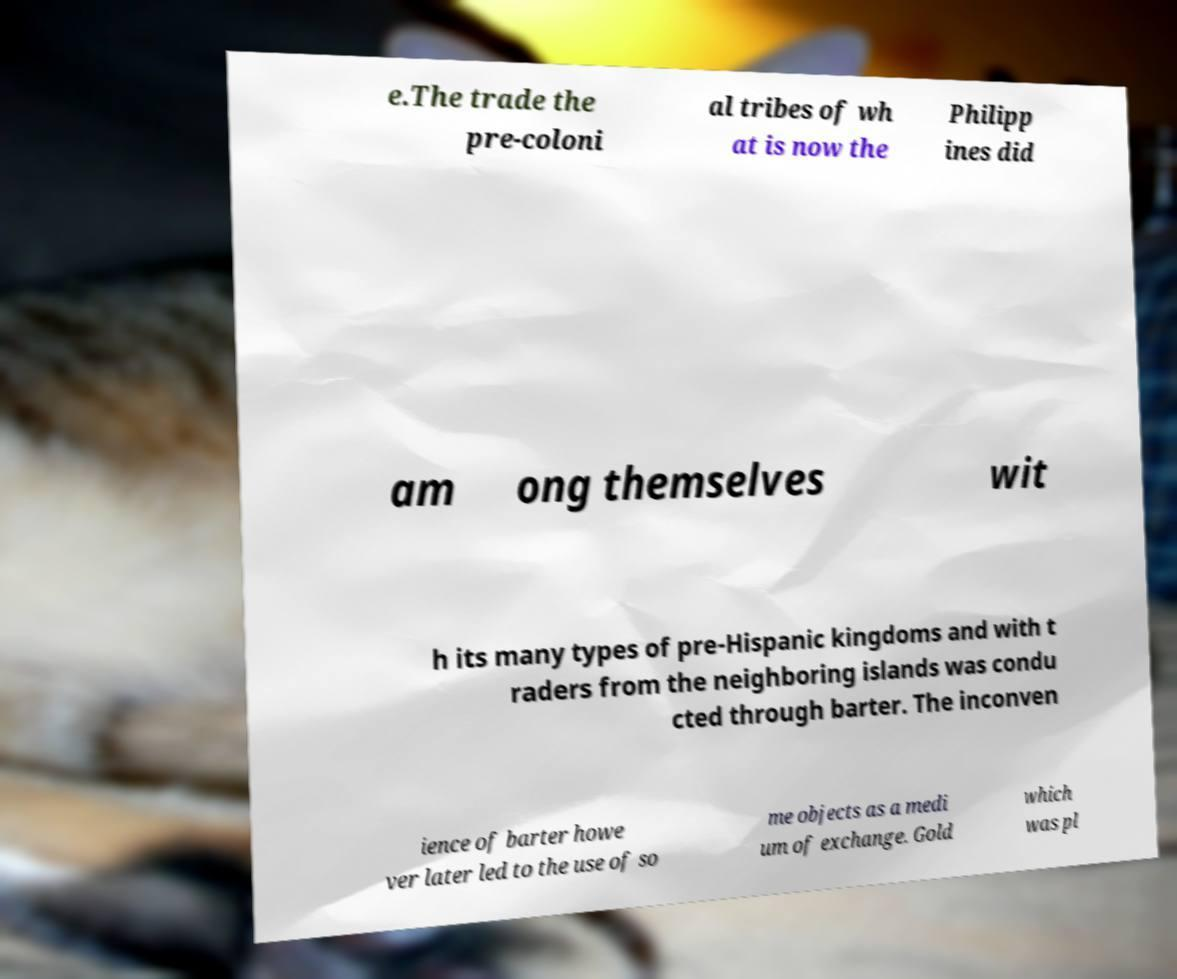Please read and relay the text visible in this image. What does it say? e.The trade the pre-coloni al tribes of wh at is now the Philipp ines did am ong themselves wit h its many types of pre-Hispanic kingdoms and with t raders from the neighboring islands was condu cted through barter. The inconven ience of barter howe ver later led to the use of so me objects as a medi um of exchange. Gold which was pl 